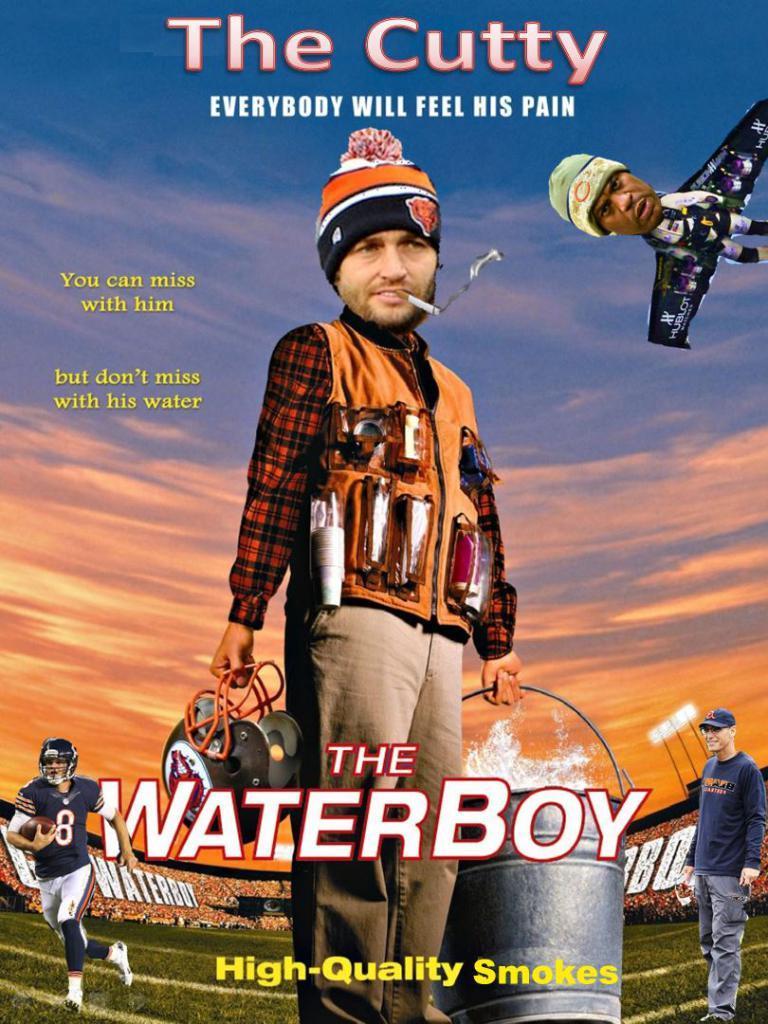In one or two sentences, can you explain what this image depicts? In this image we can see an advertisement. 